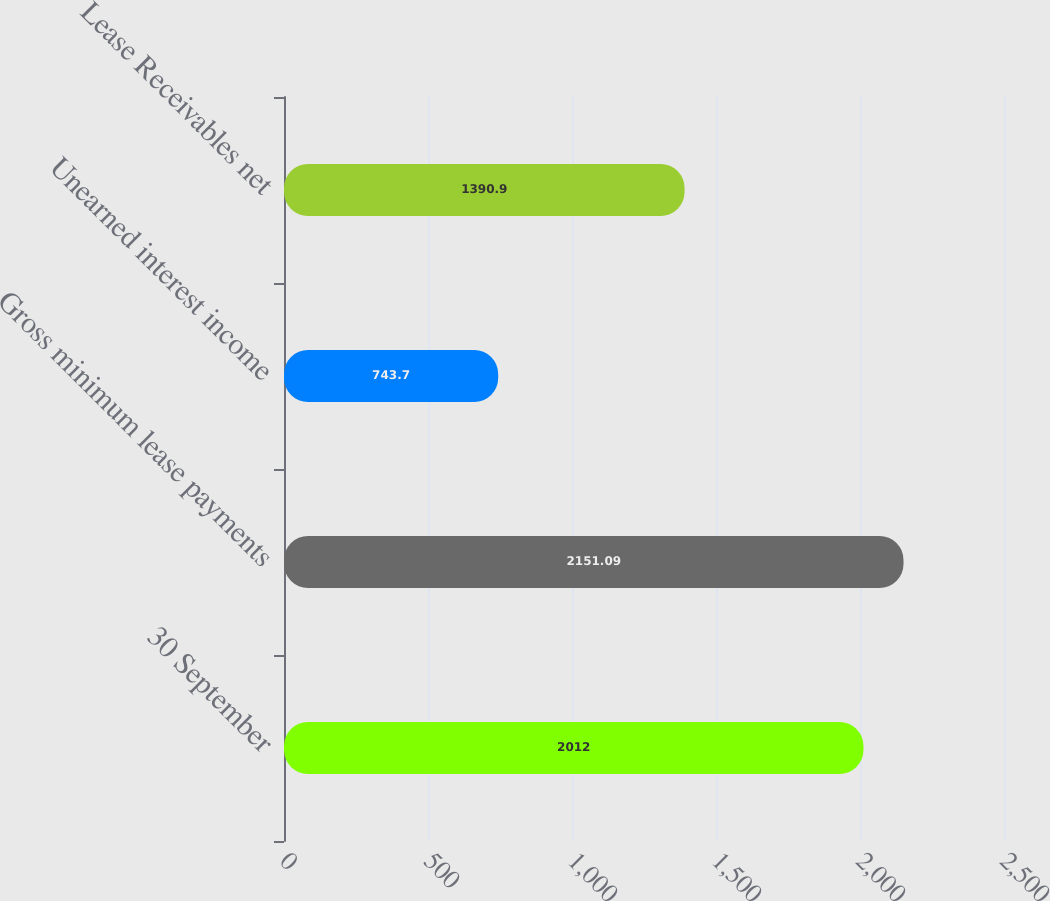Convert chart to OTSL. <chart><loc_0><loc_0><loc_500><loc_500><bar_chart><fcel>30 September<fcel>Gross minimum lease payments<fcel>Unearned interest income<fcel>Lease Receivables net<nl><fcel>2012<fcel>2151.09<fcel>743.7<fcel>1390.9<nl></chart> 